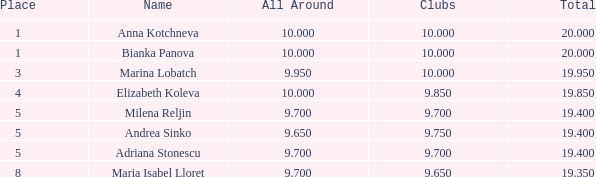Can you parse all the data within this table? {'header': ['Place', 'Name', 'All Around', 'Clubs', 'Total'], 'rows': [['1', 'Anna Kotchneva', '10.000', '10.000', '20.000'], ['1', 'Bianka Panova', '10.000', '10.000', '20.000'], ['3', 'Marina Lobatch', '9.950', '10.000', '19.950'], ['4', 'Elizabeth Koleva', '10.000', '9.850', '19.850'], ['5', 'Milena Reljin', '9.700', '9.700', '19.400'], ['5', 'Andrea Sinko', '9.650', '9.750', '19.400'], ['5', 'Adriana Stonescu', '9.700', '9.700', '19.400'], ['8', 'Maria Isabel Lloret', '9.700', '9.650', '19.350']]} What is the count of places where bianka panova's name is present and the clubs have less than 10 members? 0.0. 